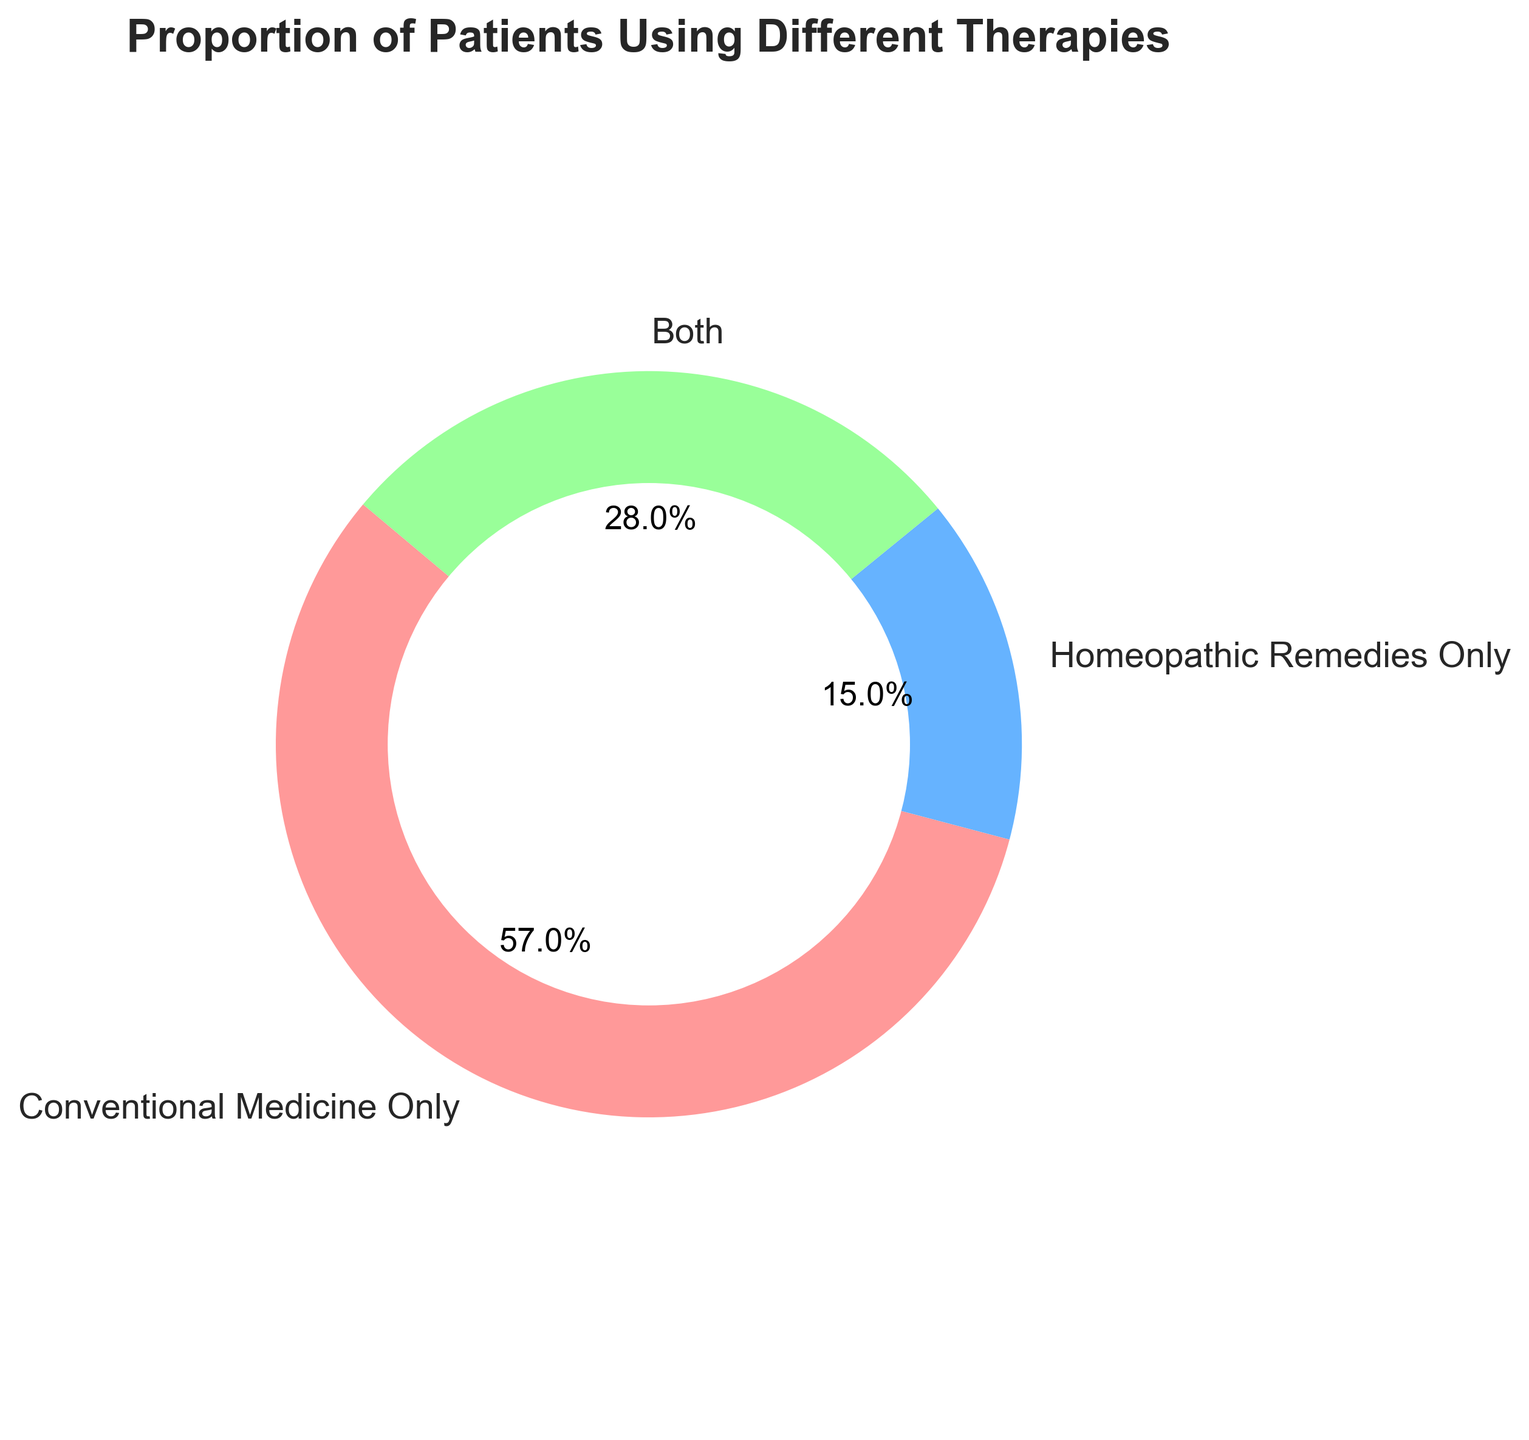What percentage of patients use both conventional medicine and homeopathic remedies? The pie chart displays three categories: Conventional Medicine Only, Homeopathic Remedies Only, and Both. The section labeled "Both" shows a value of 28%.
Answer: 28% Which category has the smallest proportion of patients? The pie chart shows the proportions of each category. The category "Homeopathic Remedies Only" has the smallest proportion, which is 15%.
Answer: Homeopathic Remedies Only What is the total proportion of patients who use only one type of treatment? To find the total proportion of patients using only one type of treatment, add the sections "Conventional Medicine Only" and "Homeopathic Remedies Only". That is 57% + 15% = 72%.
Answer: 72% Do more patients use some form of conventional medicine (Conventional Medicine Only + Both) or homeopathic remedies (Homeopathic Remedies Only + Both)? To compare, add the proportions for each form. Conventional Medicine: 57% + 28% = 85%. Homeopathic Remedies: 15% + 28% = 43%. 85% is greater than 43%.
Answer: Conventional Medicine By how much does the proportion of patients using conventional medicine only exceed those using only homeopathic remedies? Subtract the proportion of "Homeopathic Remedies Only" from that of "Conventional Medicine Only": 57% - 15% = 42%.
Answer: 42% What color represents the category with the largest proportion of patients? The category with the largest proportion is "Conventional Medicine Only" and it is represented by the color red.
Answer: Red Is the sum of the proportions for patients using conventional medicine only and both therapies greater than the proportion of patients using homeopathic remedies only by more than 60%? First, sum the proportions for "Conventional Medicine Only" and "Both" which is 57% + 28% = 85%. Next, subtract "Homeopathic Remedies Only" from it: 85% - 15% = 70%. Since 70% > 60%, the answer is yes.
Answer: Yes Which category is represented by the green section of the pie chart? The green section of the pie chart represents the category "Both".
Answer: Both What is the difference in proportions between the categories with the highest and lowest percentages? The highest category is "Conventional Medicine Only" at 57%. The lowest is "Homeopathic Remedies Only" at 15%. The difference is 57% - 15% = 42%.
Answer: 42% What is the average proportion of patients across all three categories? To find the average, sum the proportions and divide by the number of categories: (57% + 15% + 28%) / 3 = 100% / 3 ≈ 33.33%.
Answer: 33.33% 